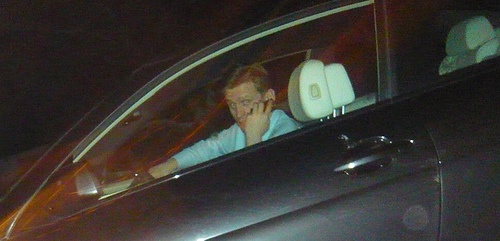Describe the objects in this image and their specific colors. I can see car in black, maroon, and gray tones, people in black, teal, and gray tones, and cell phone in black, maroon, and gray tones in this image. 